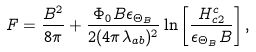Convert formula to latex. <formula><loc_0><loc_0><loc_500><loc_500>F = \frac { B ^ { 2 } } { 8 \pi } + \frac { \Phi _ { 0 } B \epsilon _ { \Theta _ { B } } } { 2 ( 4 \pi \lambda _ { a b } ) ^ { 2 } } \ln \left [ \frac { H ^ { c } _ { c 2 } } { \epsilon _ { \Theta _ { B } } B } \right ] ,</formula> 